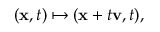Convert formula to latex. <formula><loc_0><loc_0><loc_500><loc_500>( x , t ) \mapsto ( x + t v , t ) ,</formula> 